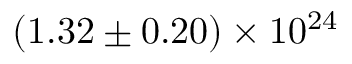Convert formula to latex. <formula><loc_0><loc_0><loc_500><loc_500>{ ( 1 . 3 2 \pm 0 . 2 0 ) \times 1 0 ^ { 2 4 } }</formula> 